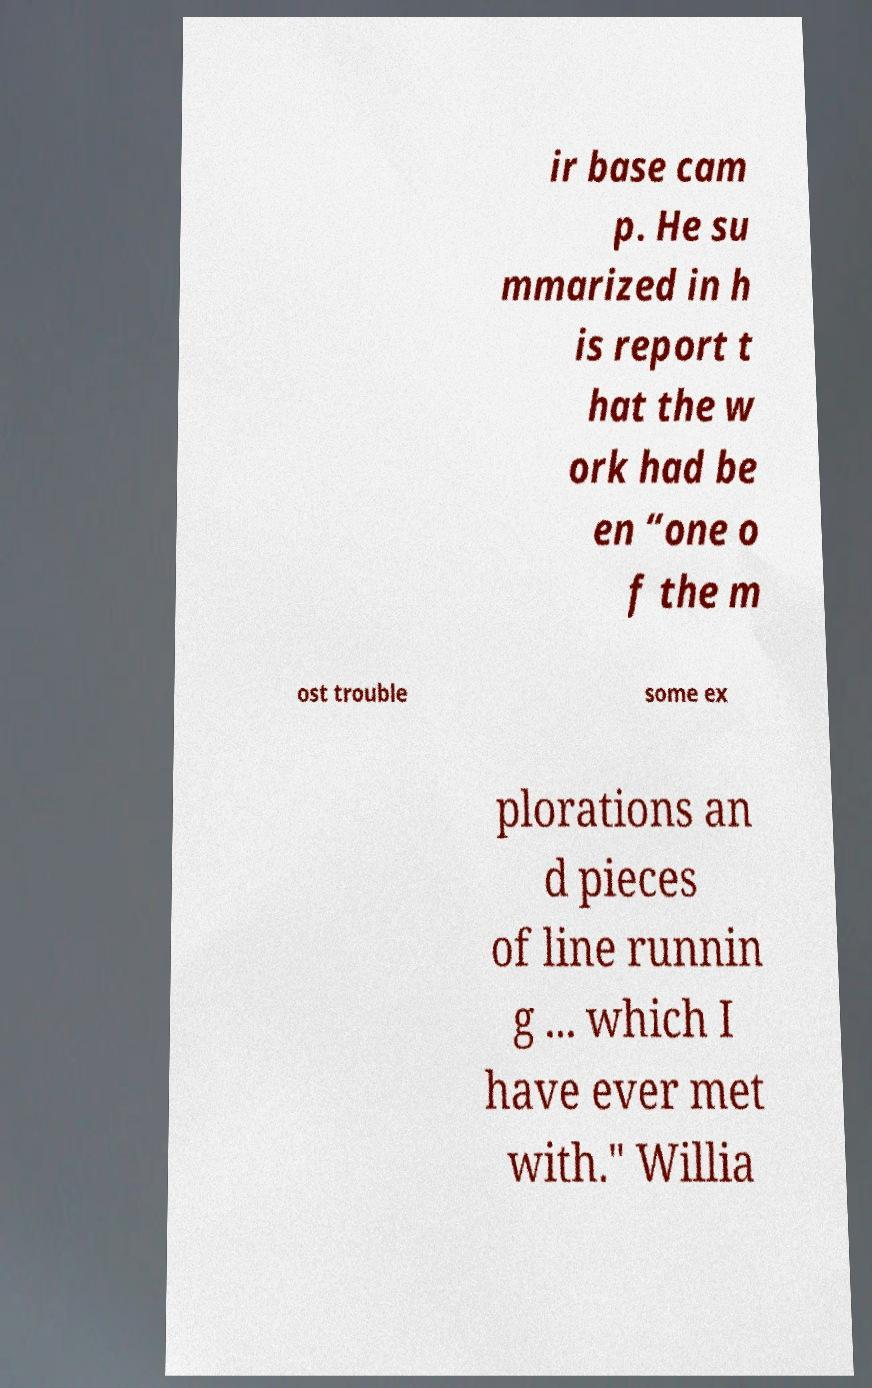Could you extract and type out the text from this image? ir base cam p. He su mmarized in h is report t hat the w ork had be en “one o f the m ost trouble some ex plorations an d pieces of line runnin g ... which I have ever met with." Willia 